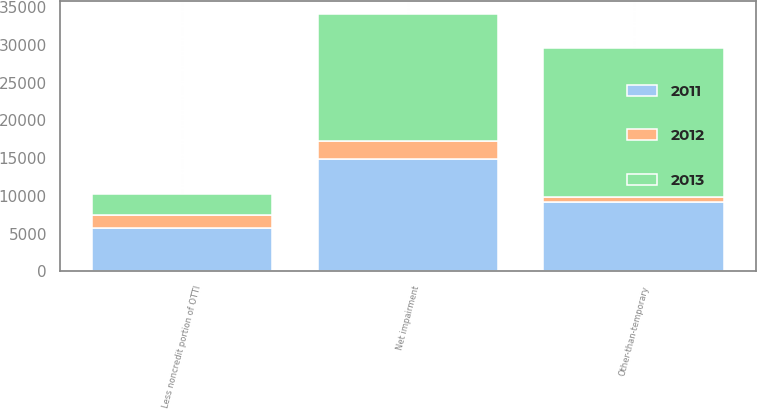<chart> <loc_0><loc_0><loc_500><loc_500><stacked_bar_chart><ecel><fcel>Other-than-temporary<fcel>Less noncredit portion of OTTI<fcel>Net impairment<nl><fcel>2012<fcel>632<fcel>1699<fcel>2331<nl><fcel>2013<fcel>19799<fcel>2874<fcel>16925<nl><fcel>2011<fcel>9190<fcel>5717<fcel>14907<nl></chart> 